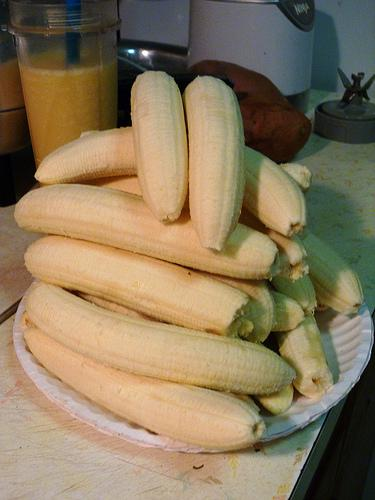Question: what color is the plate?
Choices:
A. Blue.
B. Green.
C. Yellow.
D. White.
Answer with the letter. Answer: D Question: how many people are in the picture?
Choices:
A. 5.
B. 6.
C. 8.
D. None.
Answer with the letter. Answer: D Question: what fruit is in the picture?
Choices:
A. Apples.
B. Pears.
C. Bananas.
D. Strawberries.
Answer with the letter. Answer: C Question: where are the bananas sitting?
Choices:
A. On a plate.
B. On the counter.
C. In the kitchen.
D. In the bowl.
Answer with the letter. Answer: A 